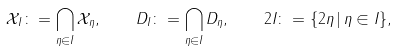Convert formula to latex. <formula><loc_0><loc_0><loc_500><loc_500>\mathcal { X } _ { I } \colon = \bigcap _ { \eta \in I } \mathcal { X } _ { \eta } , \quad D _ { I } \colon = \bigcap _ { \eta \in I } D _ { \eta } , \quad 2 I \colon = \{ 2 \eta \, | \, \eta \in I \} ,</formula> 